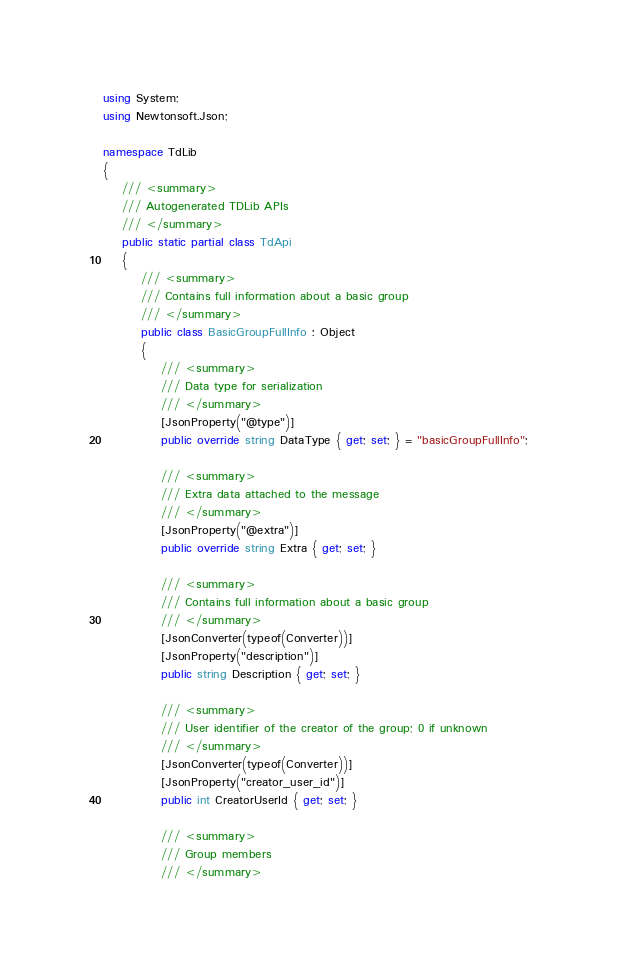Convert code to text. <code><loc_0><loc_0><loc_500><loc_500><_C#_>using System;
using Newtonsoft.Json;

namespace TdLib
{
    /// <summary>
    /// Autogenerated TDLib APIs
    /// </summary>
    public static partial class TdApi
    {
        /// <summary>
        /// Contains full information about a basic group 
        /// </summary>
        public class BasicGroupFullInfo : Object
        {
            /// <summary>
            /// Data type for serialization
            /// </summary>
            [JsonProperty("@type")]
            public override string DataType { get; set; } = "basicGroupFullInfo";

            /// <summary>
            /// Extra data attached to the message
            /// </summary>
            [JsonProperty("@extra")]
            public override string Extra { get; set; }

            /// <summary>
            /// Contains full information about a basic group 
            /// </summary>
            [JsonConverter(typeof(Converter))]
            [JsonProperty("description")]
            public string Description { get; set; }

            /// <summary>
            /// User identifier of the creator of the group; 0 if unknown 
            /// </summary>
            [JsonConverter(typeof(Converter))]
            [JsonProperty("creator_user_id")]
            public int CreatorUserId { get; set; }

            /// <summary>
            /// Group members 
            /// </summary></code> 